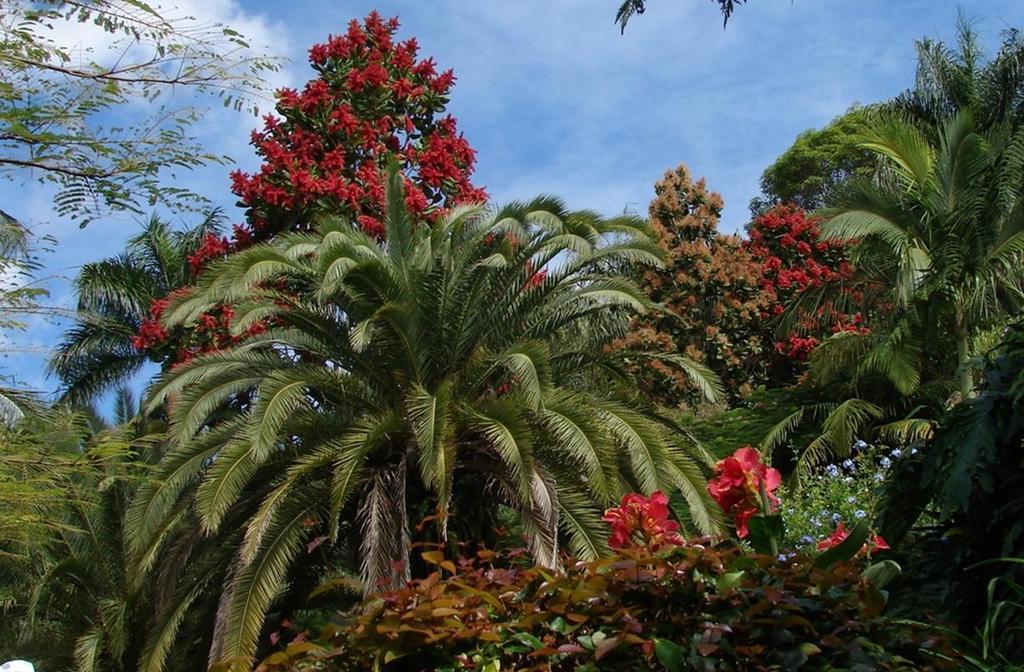Please provide a concise description of this image. In this picture there are different types of trees and there are flowers on the trees. At the top there is sky and there are clouds. 